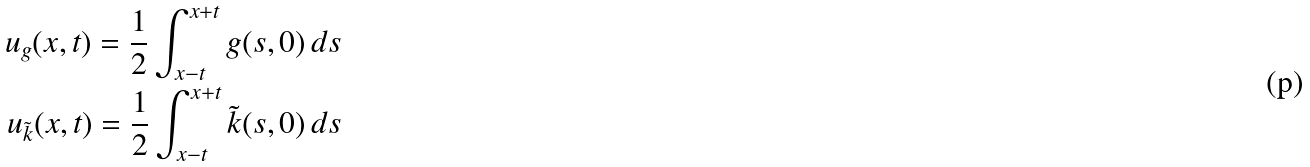Convert formula to latex. <formula><loc_0><loc_0><loc_500><loc_500>u _ { g } ( x , t ) = \frac { 1 } { 2 } \int _ { x - t } ^ { x + t } g ( s , 0 ) \, d s \\ u _ { \tilde { k } } ( x , t ) = \frac { 1 } { 2 } \int _ { x - t } ^ { x + t } \tilde { k } ( s , 0 ) \, d s</formula> 